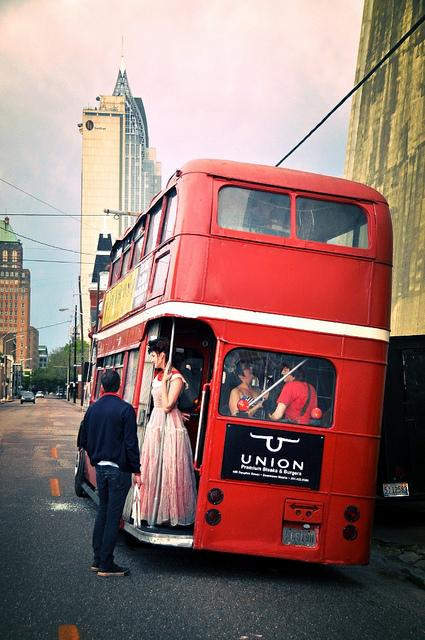What is the purpose of the wires above the vehicle?

Choices:
A) for climbing
B) for swinging
C) power source
D) for decoration power source 